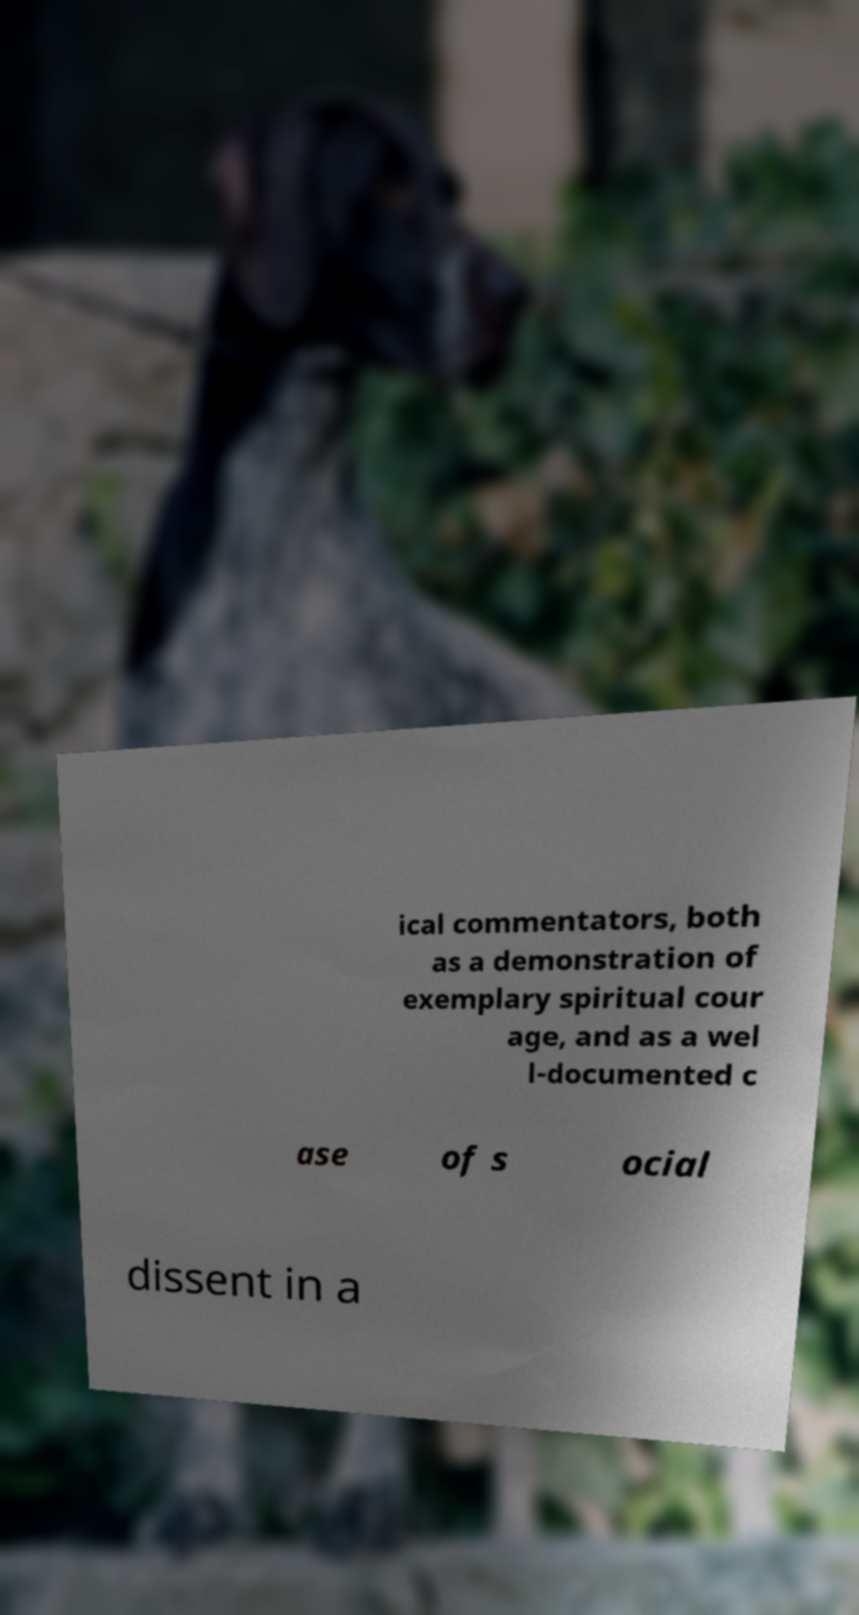Can you read and provide the text displayed in the image?This photo seems to have some interesting text. Can you extract and type it out for me? ical commentators, both as a demonstration of exemplary spiritual cour age, and as a wel l-documented c ase of s ocial dissent in a 